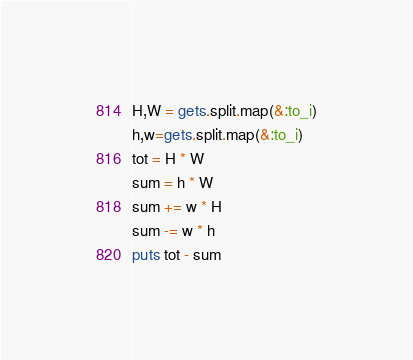Convert code to text. <code><loc_0><loc_0><loc_500><loc_500><_Ruby_>H,W = gets.split.map(&:to_i)
h,w=gets.split.map(&:to_i)
tot = H * W
sum = h * W
sum += w * H
sum -= w * h
puts tot - sum</code> 